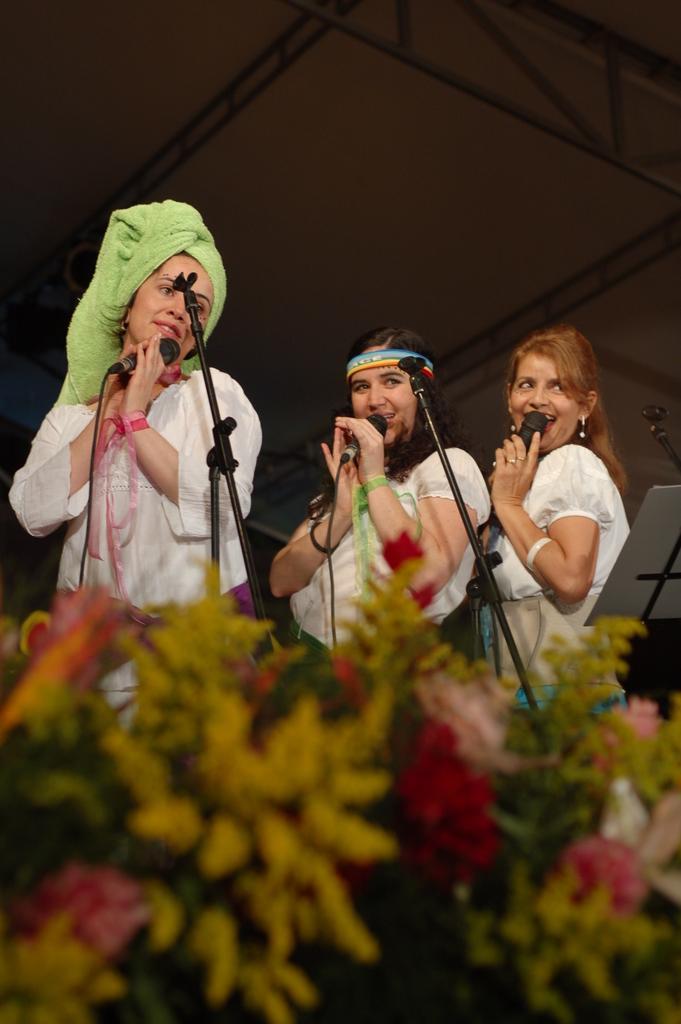Can you describe this image briefly? In this picture we can see few women, they are holding microphones, in front of them we can find a stand and flowers, in the background we can see few metal rods. 